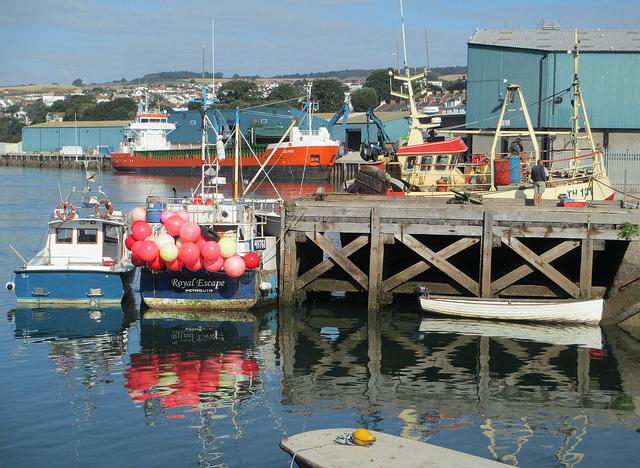Why are all those balloons in the boat?

Choices:
A) fell there
B) celebration
C) for sale
D) stolen celebration 